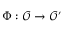<formula> <loc_0><loc_0><loc_500><loc_500>\Phi \colon { \mathcal { O } } \rightarrow { \mathcal { O } } ^ { \prime }</formula> 